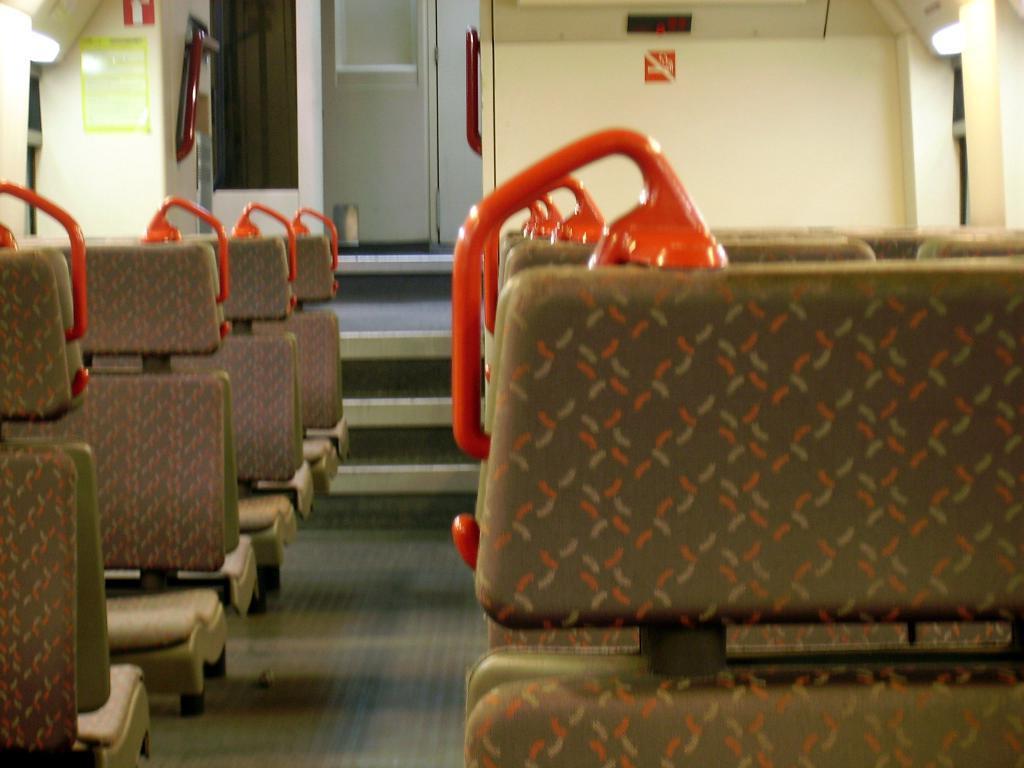Please provide a concise description of this image. In this image, we can see some seats, we can see the white wall and a door. 